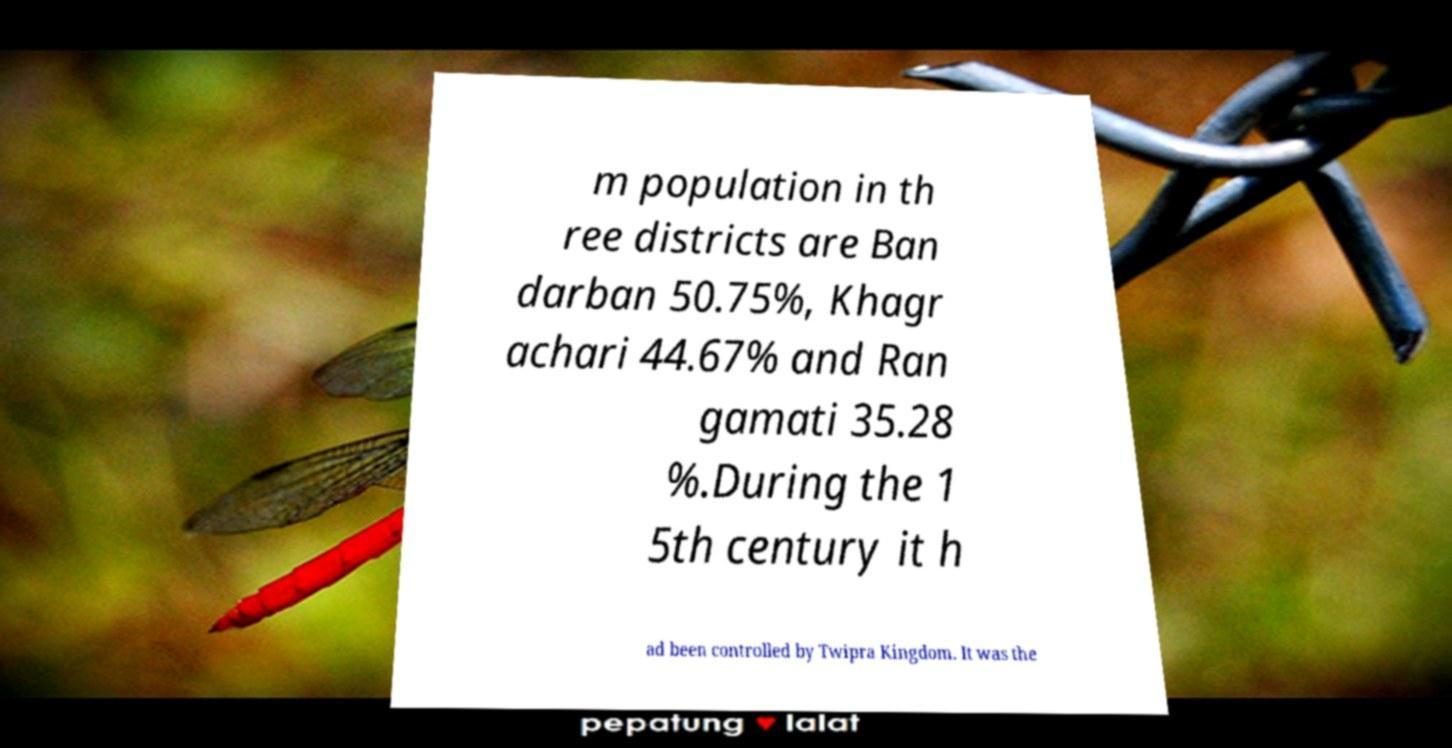Could you extract and type out the text from this image? m population in th ree districts are Ban darban 50.75%, Khagr achari 44.67% and Ran gamati 35.28 %.During the 1 5th century it h ad been controlled by Twipra Kingdom. It was the 